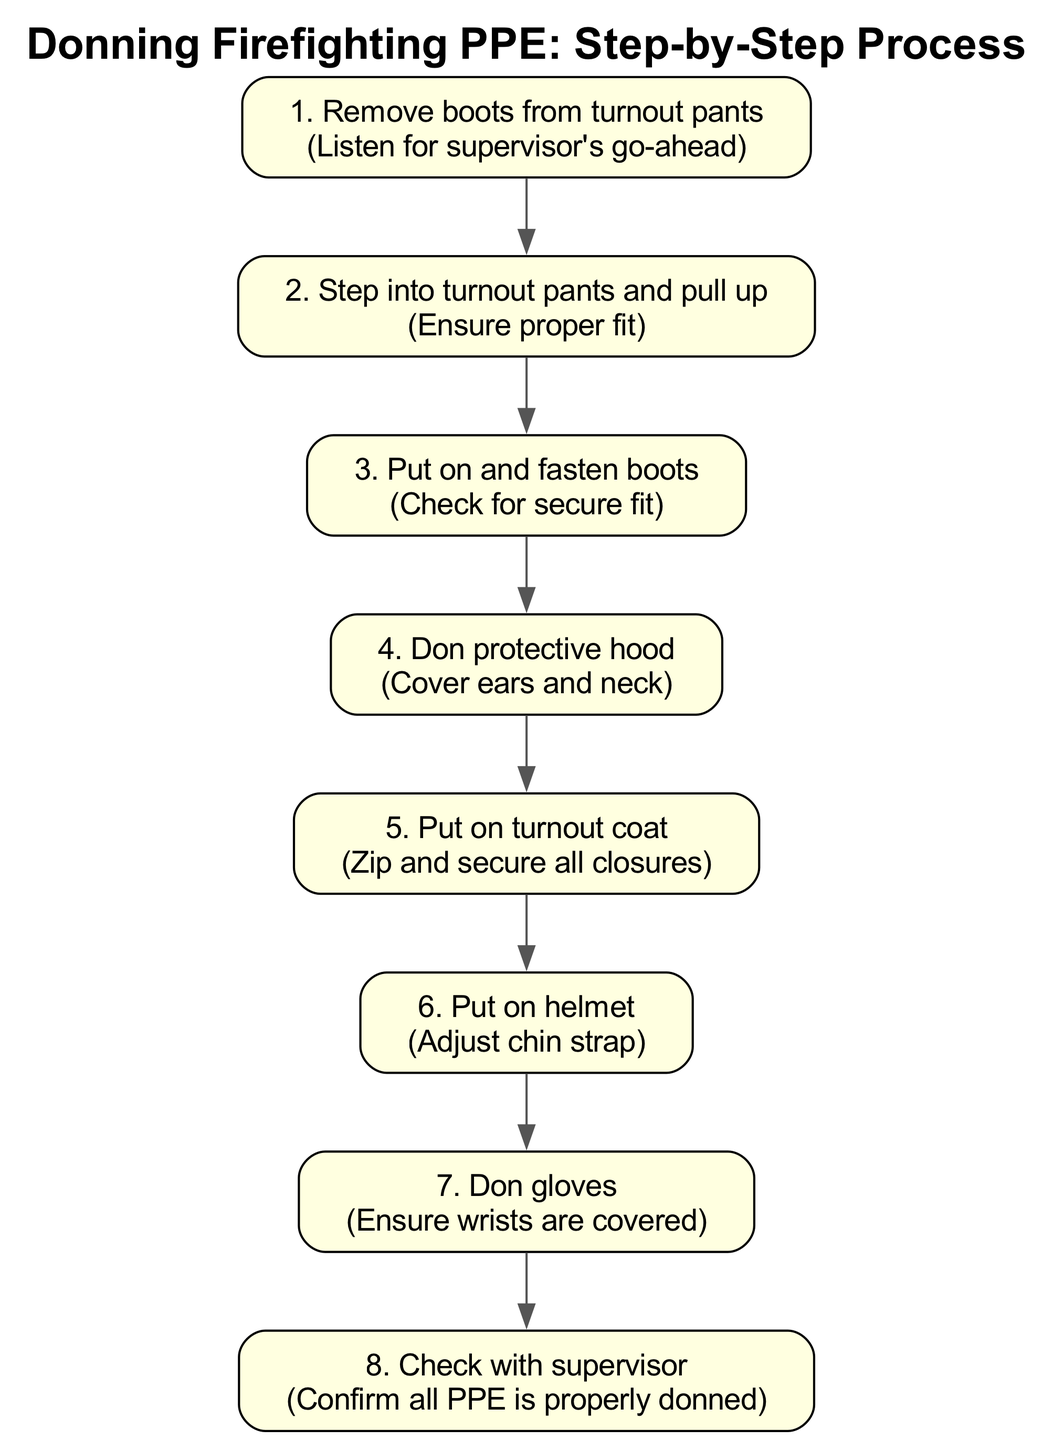What is the first step in the process? The diagram clearly indicates that the first step is labeled as "1. Remove boots from turnout pants." This is directly found in the list of steps provided.
Answer: Remove boots from turnout pants How many total steps are there in the donning process? By counting the steps listed in the diagram, we see there are eight steps in total. Each step is numbered sequentially from 1 to 8.
Answer: 8 What step comes after putting on the helmet? The diagram shows a clear order of steps. After "Put on helmet," which is step 6, the next step is "Don gloves," which is step 7.
Answer: Don gloves Which step includes checking for a secure fit of boots? The step labeled as "3. Put on and fasten boots" includes the note "Check for secure fit." This indicates that checking for a fit occurs during this step.
Answer: Put on and fasten boots What is the final step before checking with the supervisor? According to the diagram, the final step before checking with the supervisor, which is step 8, is "Don gloves," which is step 7. This means gloves are donned prior to the confirmation with the supervisor.
Answer: Don gloves What action is emphasized in the note of the fourth step? The fourth step is "Don protective hood," and the note emphasizes "Cover ears and neck." This indicates the importance of protecting these areas.
Answer: Cover ears and neck Which step requires adjusting the chin strap? The sixth step states "Put on helmet," with a note about adjusting the chin strap. This shows that the chin strap adjustment is a part of this step.
Answer: Put on helmet How is the relationship between steps 2 and 3 described? The relationship is a sequential one, with step 2 being "Step into turnout pants and pull up" followed directly by step 3, "Put on and fasten boots." This indicates that after completing step 2, step 3 follows immediately.
Answer: Sequential relationship 